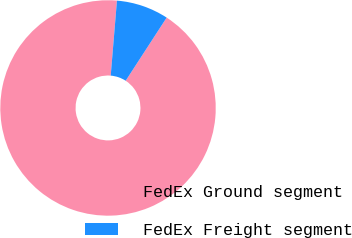Convert chart. <chart><loc_0><loc_0><loc_500><loc_500><pie_chart><fcel>FedEx Ground segment<fcel>FedEx Freight segment<nl><fcel>92.16%<fcel>7.84%<nl></chart> 